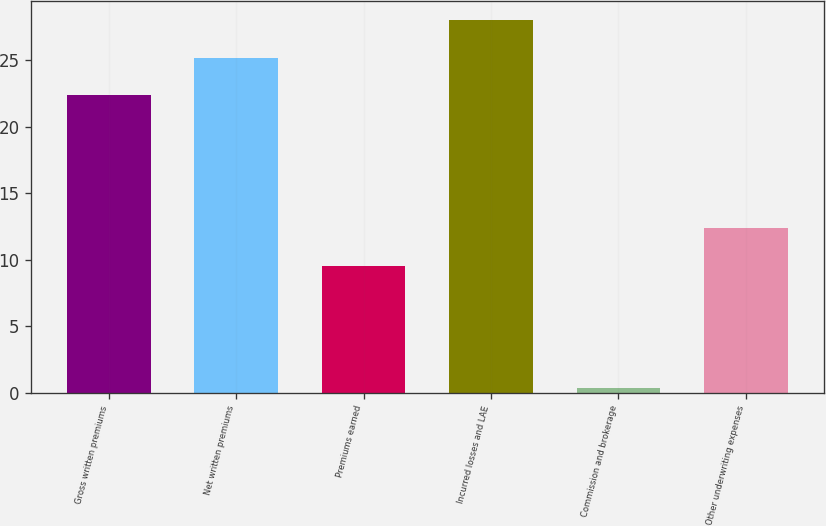Convert chart to OTSL. <chart><loc_0><loc_0><loc_500><loc_500><bar_chart><fcel>Gross written premiums<fcel>Net written premiums<fcel>Premiums earned<fcel>Incurred losses and LAE<fcel>Commission and brokerage<fcel>Other underwriting expenses<nl><fcel>22.4<fcel>25.16<fcel>9.5<fcel>28<fcel>0.4<fcel>12.4<nl></chart> 